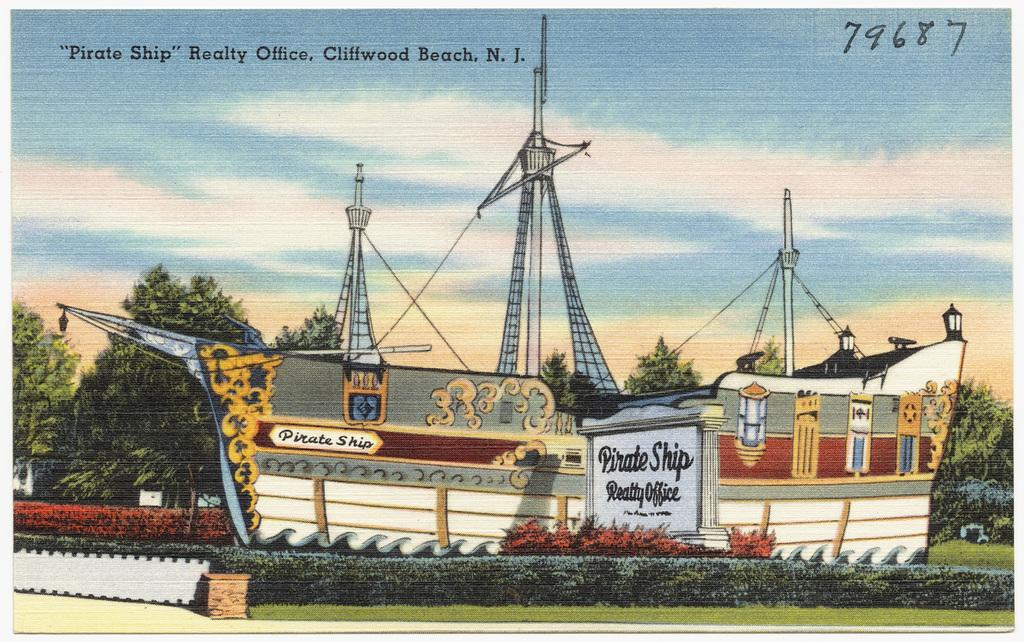What type of visual content is the image? The image is a poster. What is the main subject of the poster? There is a boat in the image. What other objects are present in the image? There are boards, poles, plants, and trees in the image. What can be seen in the background of the image? The sky with clouds is visible in the background of the image. How many apples are hanging from the trees in the image? There are no apples present in the image; only plants and trees can be seen. What type of spot can be seen on the boat in the image? There is no spot visible on the boat in the image. 